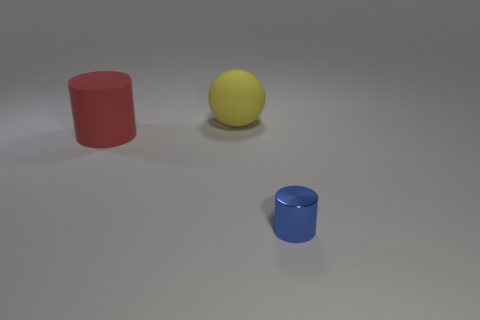There is a thing that is in front of the large matte object in front of the yellow thing; what is its shape? cylinder 